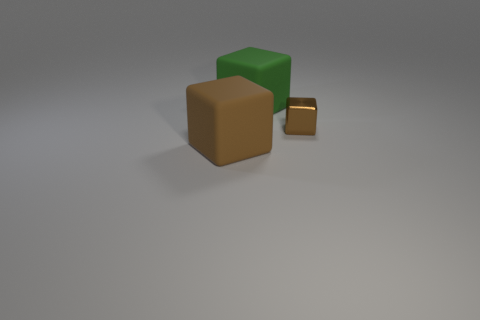Is there any other thing that is the same size as the metal thing?
Make the answer very short. No. The brown metallic object is what size?
Provide a succinct answer. Small. Does the block on the right side of the big green rubber thing have the same size as the rubber object that is behind the brown matte block?
Your response must be concise. No. What is the size of the other green rubber object that is the same shape as the small object?
Offer a terse response. Large. There is a green rubber block; does it have the same size as the brown object that is right of the large brown object?
Make the answer very short. No. Are there any cubes on the right side of the large thing that is in front of the large green rubber object?
Keep it short and to the point. Yes. There is a object that is in front of the tiny brown thing; what is its shape?
Ensure brevity in your answer.  Cube. There is another object that is the same color as the tiny metal thing; what is its material?
Ensure brevity in your answer.  Rubber. There is a large matte cube to the right of the rubber cube on the left side of the green rubber object; what is its color?
Give a very brief answer. Green. Do the green rubber object and the brown rubber thing have the same size?
Your answer should be compact. Yes. 